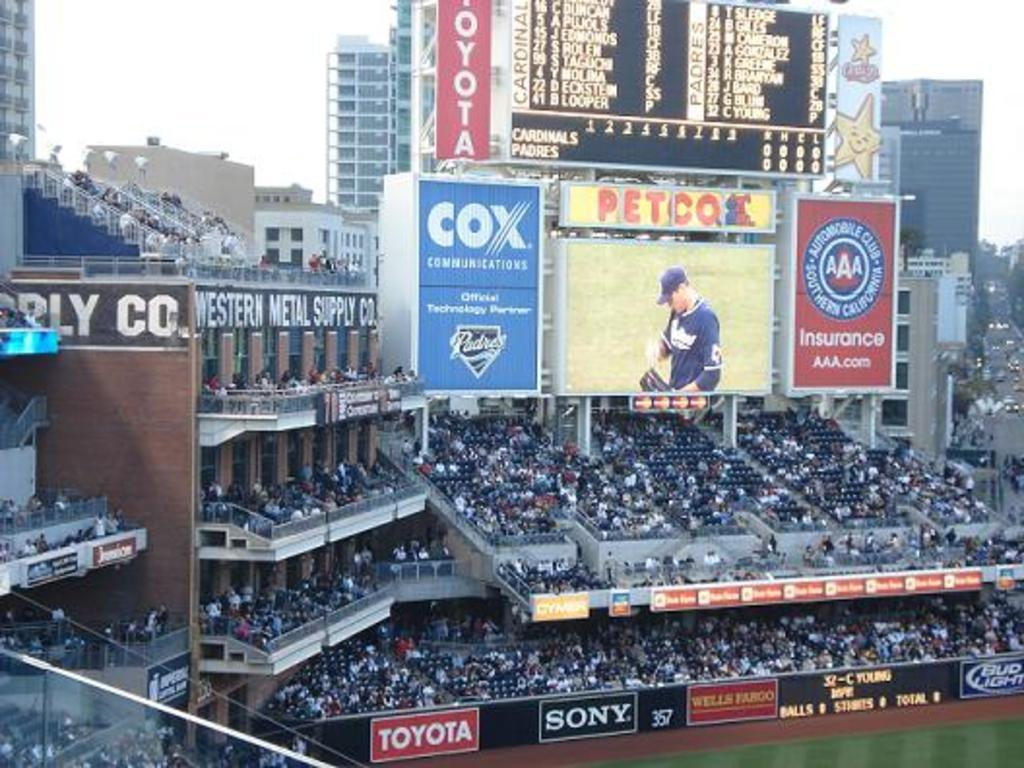<image>
Relay a brief, clear account of the picture shown. A Cox advertisement is above the fans at the stadium 